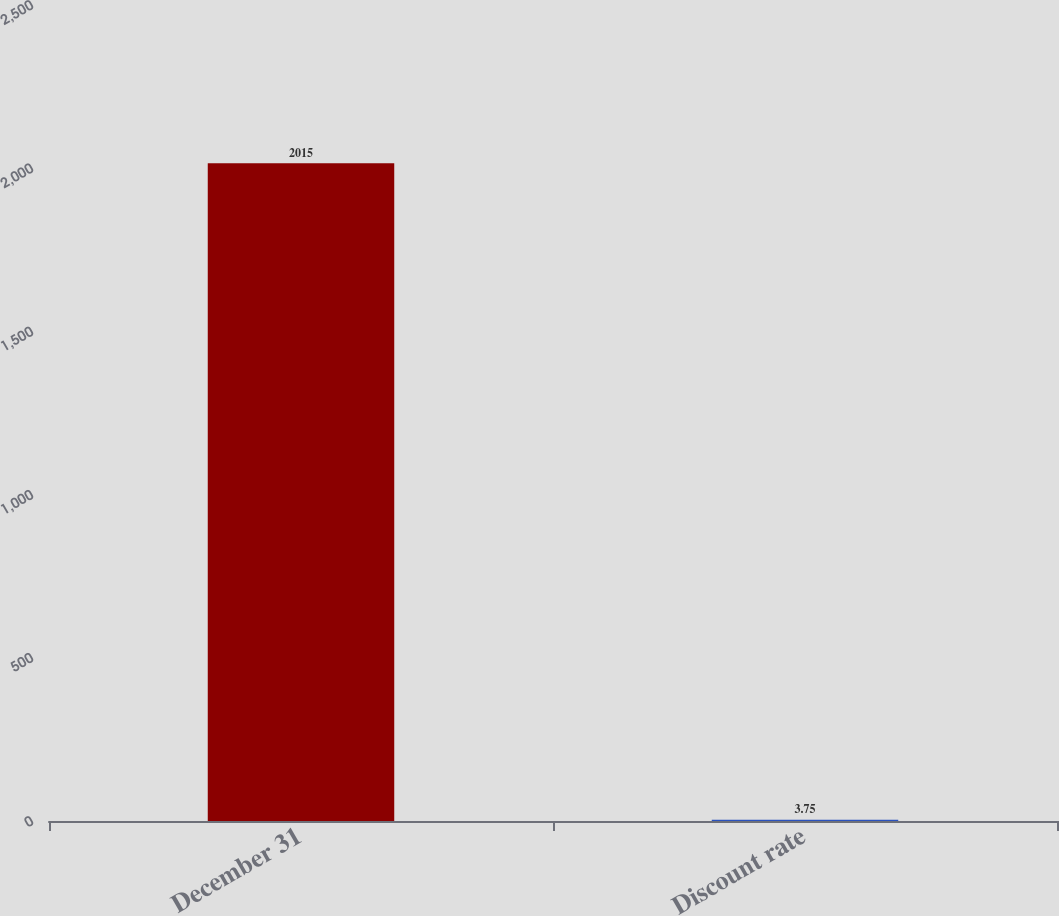Convert chart. <chart><loc_0><loc_0><loc_500><loc_500><bar_chart><fcel>December 31<fcel>Discount rate<nl><fcel>2015<fcel>3.75<nl></chart> 